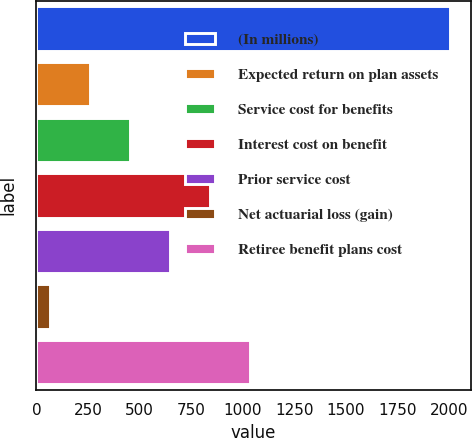<chart> <loc_0><loc_0><loc_500><loc_500><bar_chart><fcel>(In millions)<fcel>Expected return on plan assets<fcel>Service cost for benefits<fcel>Interest cost on benefit<fcel>Prior service cost<fcel>Net actuarial loss (gain)<fcel>Retiree benefit plans cost<nl><fcel>2006<fcel>258.2<fcel>452.4<fcel>840.8<fcel>646.6<fcel>64<fcel>1035<nl></chart> 